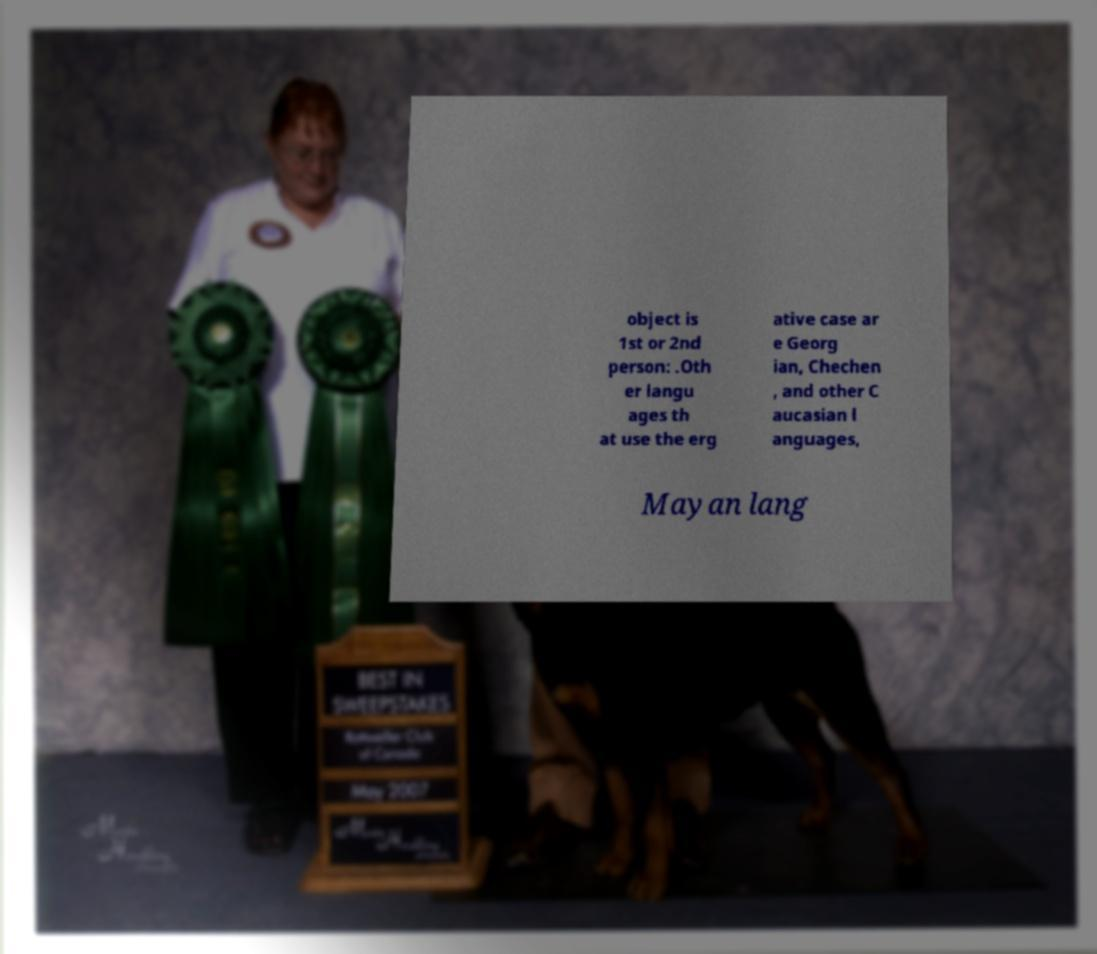Please identify and transcribe the text found in this image. object is 1st or 2nd person: .Oth er langu ages th at use the erg ative case ar e Georg ian, Chechen , and other C aucasian l anguages, Mayan lang 